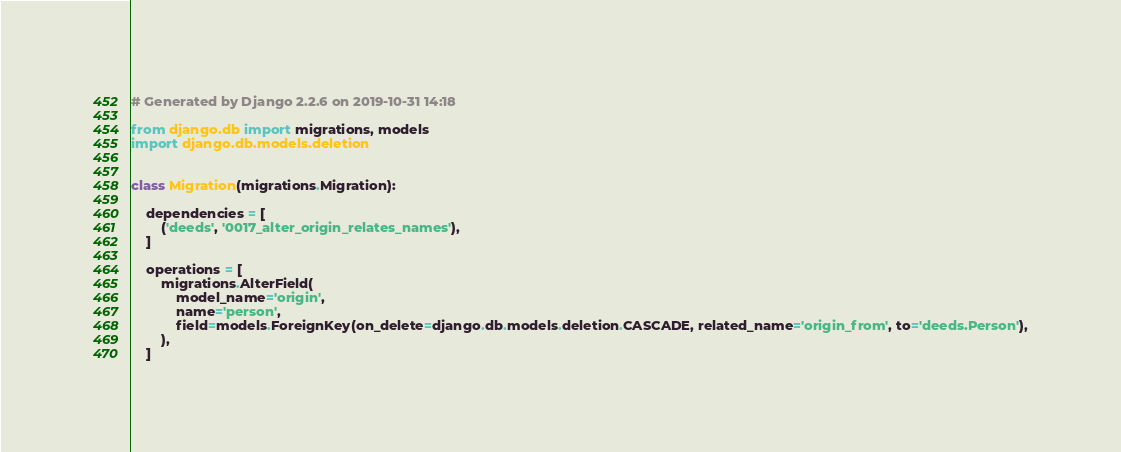Convert code to text. <code><loc_0><loc_0><loc_500><loc_500><_Python_># Generated by Django 2.2.6 on 2019-10-31 14:18

from django.db import migrations, models
import django.db.models.deletion


class Migration(migrations.Migration):

    dependencies = [
        ('deeds', '0017_alter_origin_relates_names'),
    ]

    operations = [
        migrations.AlterField(
            model_name='origin',
            name='person',
            field=models.ForeignKey(on_delete=django.db.models.deletion.CASCADE, related_name='origin_from', to='deeds.Person'),
        ),
    ]
</code> 